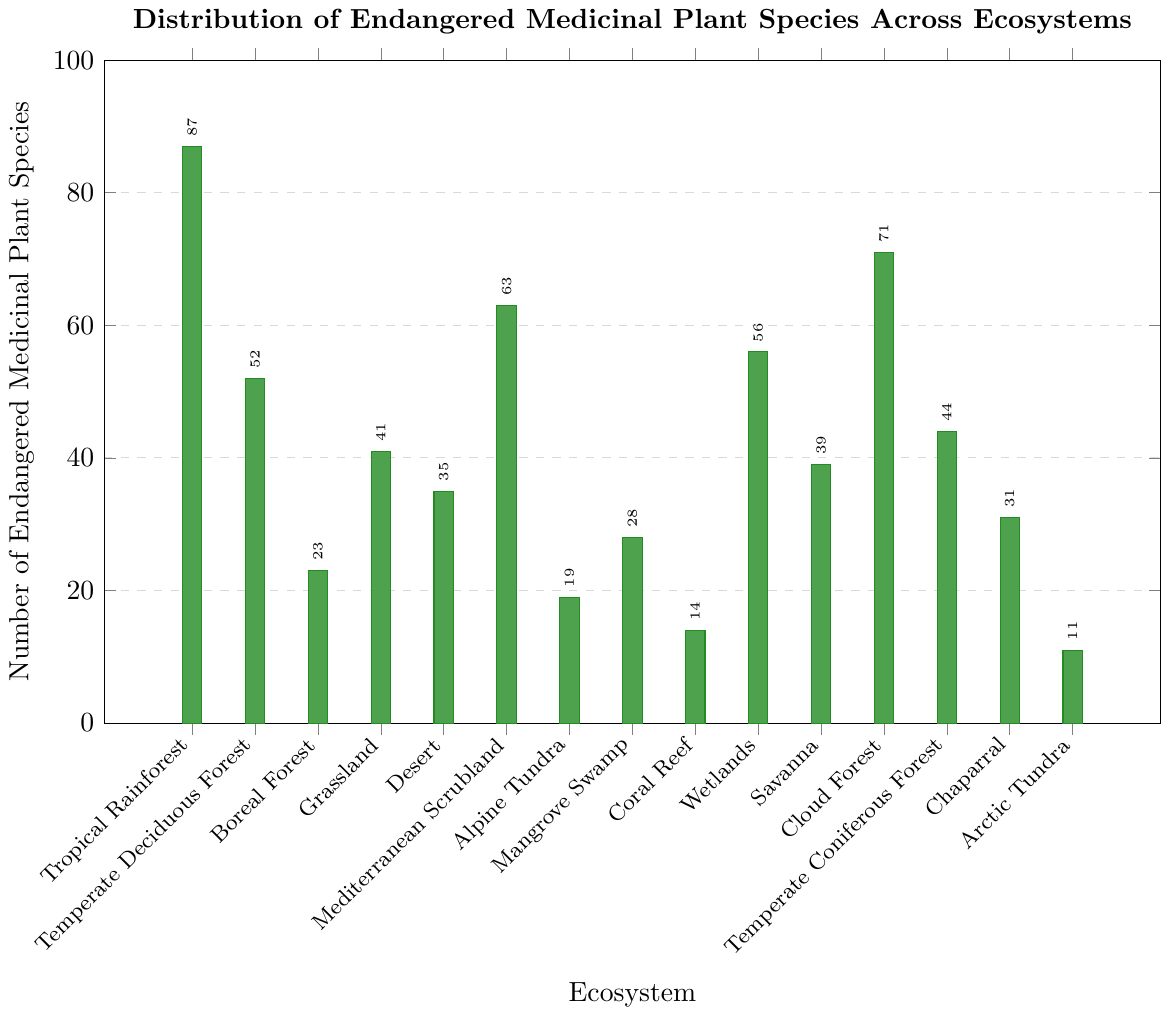What ecosystem has the highest number of endangered medicinal plant species? The ecosystem with the tallest bar represents the ecosystem with the highest number of endangered medicinal plant species. This is the Tropical Rainforest with 87 species.
Answer: Tropical Rainforest What is the second highest number of endangered medicinal plant species and in which ecosystem is it found? Identify the second tallest bar and read the value and label. The second highest is in the Cloud Forest with 71 species.
Answer: Cloud Forest, 71 What is the total number of endangered medicinal plant species in Boreal Forest, Grassland, and Desert combined? Add the values for Boreal Forest (23), Grassland (41), and Desert (35). That is 23 + 41 + 35 = 99.
Answer: 99 Which ecosystem has fewer endangered species: Mangrove Swamp or Wetlands? Compare the bar heights or values for Mangrove Swamp (28) and Wetlands (56). Mangrove Swamp has fewer species.
Answer: Mangrove Swamp How many more endangered medicinal plant species are found in Wetlands compared to Coral Reef? Subtract the number of species in Coral Reef (14) from that in Wetlands (56). That is 56 - 14 = 42.
Answer: 42 What is the average number of endangered medicinal plant species across the ecosystems Tropical Rainforest, Mediterranean Scrubland, and Cloud Forest? Calculate the average of the values for Tropical Rainforest (87), Mediterranean Scrubland (63), and Cloud Forest (71). (87 + 63 + 71) / 3 = 221 / 3 ≈ 73.67.
Answer: 73.67 Rank the ecosystems by the number of endangered medicinal plant species from highest to lowest. List the ecosystems and their values, then order the list from highest to lowest value. Tropical Rainforest (87), Cloud Forest (71), Mediterranean Scrubland (63), Wetlands (56), Temperate Deciduous Forest (52), Temperate Coniferous Forest (44), Grassland (41), Savanna (39), Desert (35), Chaparral (31), Mangrove Swamp (28), Boreal Forest (23), Alpine Tundra (19), Coral Reef (14), Arctic Tundra (11).
Answer: Tropical Rainforest, Cloud Forest, Mediterranean Scrubland, Wetlands, Temperate Deciduous Forest, Temperate Coniferous Forest, Grassland, Savanna, Desert, Chaparral, Mangrove Swamp, Boreal Forest, Alpine Tundra, Coral Reef, Arctic Tundra How many endangered medicinal plant species are there in total across all ecosystems? Sum all the values in the dataset. 87 + 52 + 23 + 41 + 35 + 63 + 19 + 28 + 14 + 56 + 39 + 71 + 44 + 31 + 11 = 614.
Answer: 614 Which ecosystem has the most similar number of endangered species to the Temperate Coniferous Forest? Find the values closest to the Temperate Coniferous Forest's 44. Comparing the values shows that Grassland with 41 is the most similar.
Answer: Grassland What's the difference in the number of endangered medicinal plant species between the ecosystem with the least species and the ecosystem with the most species? Subtract the smallest value (Arctic Tundra with 11) from the largest value (Tropical Rainforest with 87). 87 - 11 = 76.
Answer: 76 